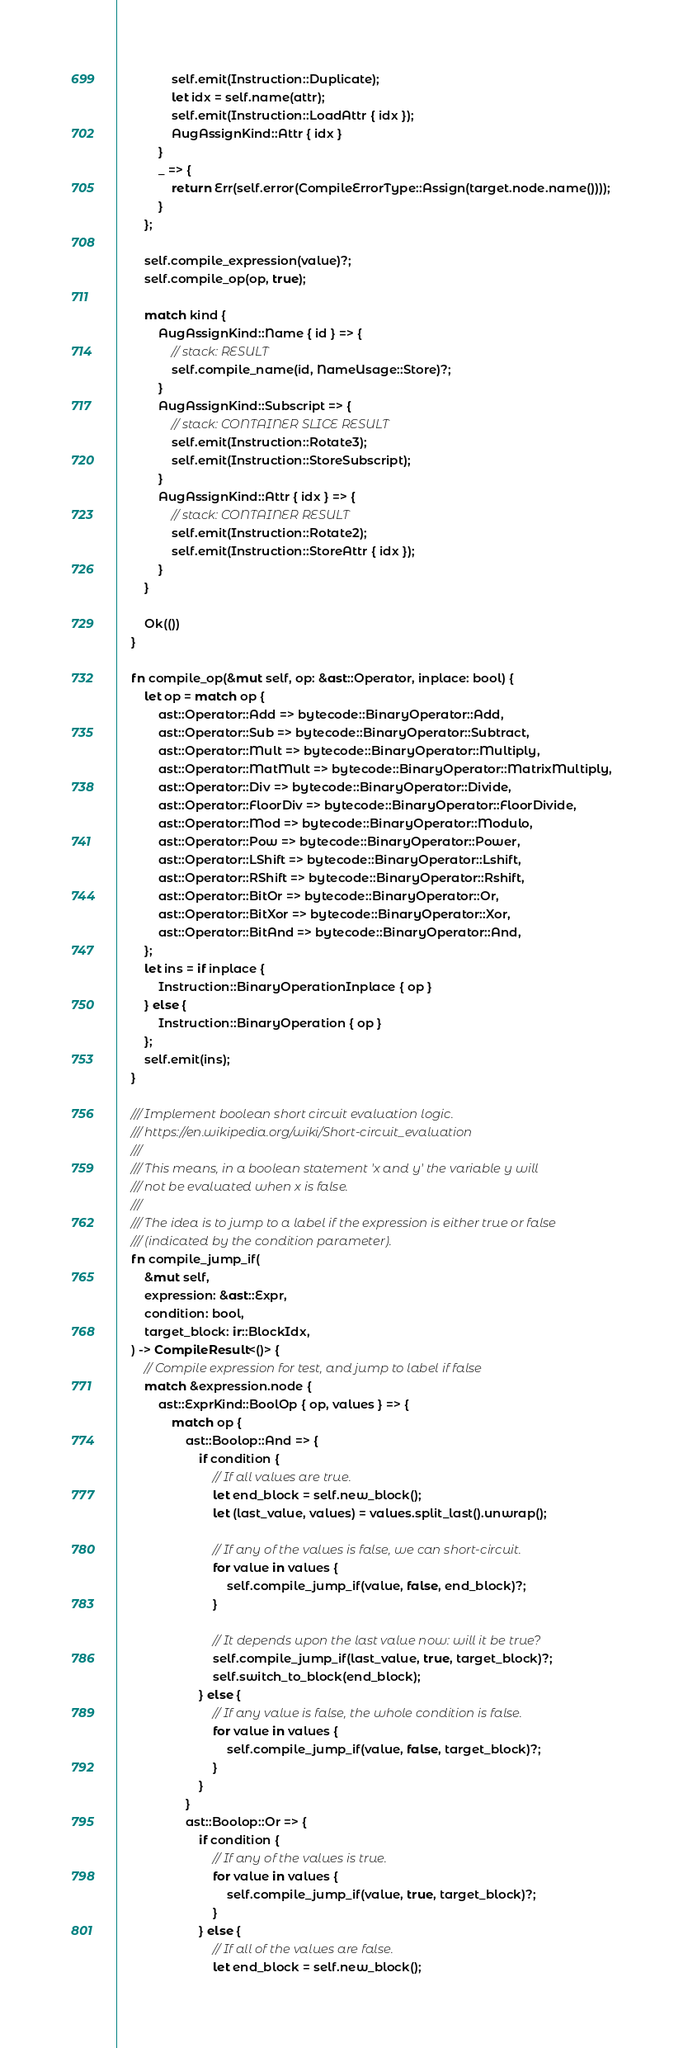Convert code to text. <code><loc_0><loc_0><loc_500><loc_500><_Rust_>                self.emit(Instruction::Duplicate);
                let idx = self.name(attr);
                self.emit(Instruction::LoadAttr { idx });
                AugAssignKind::Attr { idx }
            }
            _ => {
                return Err(self.error(CompileErrorType::Assign(target.node.name())));
            }
        };

        self.compile_expression(value)?;
        self.compile_op(op, true);

        match kind {
            AugAssignKind::Name { id } => {
                // stack: RESULT
                self.compile_name(id, NameUsage::Store)?;
            }
            AugAssignKind::Subscript => {
                // stack: CONTAINER SLICE RESULT
                self.emit(Instruction::Rotate3);
                self.emit(Instruction::StoreSubscript);
            }
            AugAssignKind::Attr { idx } => {
                // stack: CONTAINER RESULT
                self.emit(Instruction::Rotate2);
                self.emit(Instruction::StoreAttr { idx });
            }
        }

        Ok(())
    }

    fn compile_op(&mut self, op: &ast::Operator, inplace: bool) {
        let op = match op {
            ast::Operator::Add => bytecode::BinaryOperator::Add,
            ast::Operator::Sub => bytecode::BinaryOperator::Subtract,
            ast::Operator::Mult => bytecode::BinaryOperator::Multiply,
            ast::Operator::MatMult => bytecode::BinaryOperator::MatrixMultiply,
            ast::Operator::Div => bytecode::BinaryOperator::Divide,
            ast::Operator::FloorDiv => bytecode::BinaryOperator::FloorDivide,
            ast::Operator::Mod => bytecode::BinaryOperator::Modulo,
            ast::Operator::Pow => bytecode::BinaryOperator::Power,
            ast::Operator::LShift => bytecode::BinaryOperator::Lshift,
            ast::Operator::RShift => bytecode::BinaryOperator::Rshift,
            ast::Operator::BitOr => bytecode::BinaryOperator::Or,
            ast::Operator::BitXor => bytecode::BinaryOperator::Xor,
            ast::Operator::BitAnd => bytecode::BinaryOperator::And,
        };
        let ins = if inplace {
            Instruction::BinaryOperationInplace { op }
        } else {
            Instruction::BinaryOperation { op }
        };
        self.emit(ins);
    }

    /// Implement boolean short circuit evaluation logic.
    /// https://en.wikipedia.org/wiki/Short-circuit_evaluation
    ///
    /// This means, in a boolean statement 'x and y' the variable y will
    /// not be evaluated when x is false.
    ///
    /// The idea is to jump to a label if the expression is either true or false
    /// (indicated by the condition parameter).
    fn compile_jump_if(
        &mut self,
        expression: &ast::Expr,
        condition: bool,
        target_block: ir::BlockIdx,
    ) -> CompileResult<()> {
        // Compile expression for test, and jump to label if false
        match &expression.node {
            ast::ExprKind::BoolOp { op, values } => {
                match op {
                    ast::Boolop::And => {
                        if condition {
                            // If all values are true.
                            let end_block = self.new_block();
                            let (last_value, values) = values.split_last().unwrap();

                            // If any of the values is false, we can short-circuit.
                            for value in values {
                                self.compile_jump_if(value, false, end_block)?;
                            }

                            // It depends upon the last value now: will it be true?
                            self.compile_jump_if(last_value, true, target_block)?;
                            self.switch_to_block(end_block);
                        } else {
                            // If any value is false, the whole condition is false.
                            for value in values {
                                self.compile_jump_if(value, false, target_block)?;
                            }
                        }
                    }
                    ast::Boolop::Or => {
                        if condition {
                            // If any of the values is true.
                            for value in values {
                                self.compile_jump_if(value, true, target_block)?;
                            }
                        } else {
                            // If all of the values are false.
                            let end_block = self.new_block();</code> 